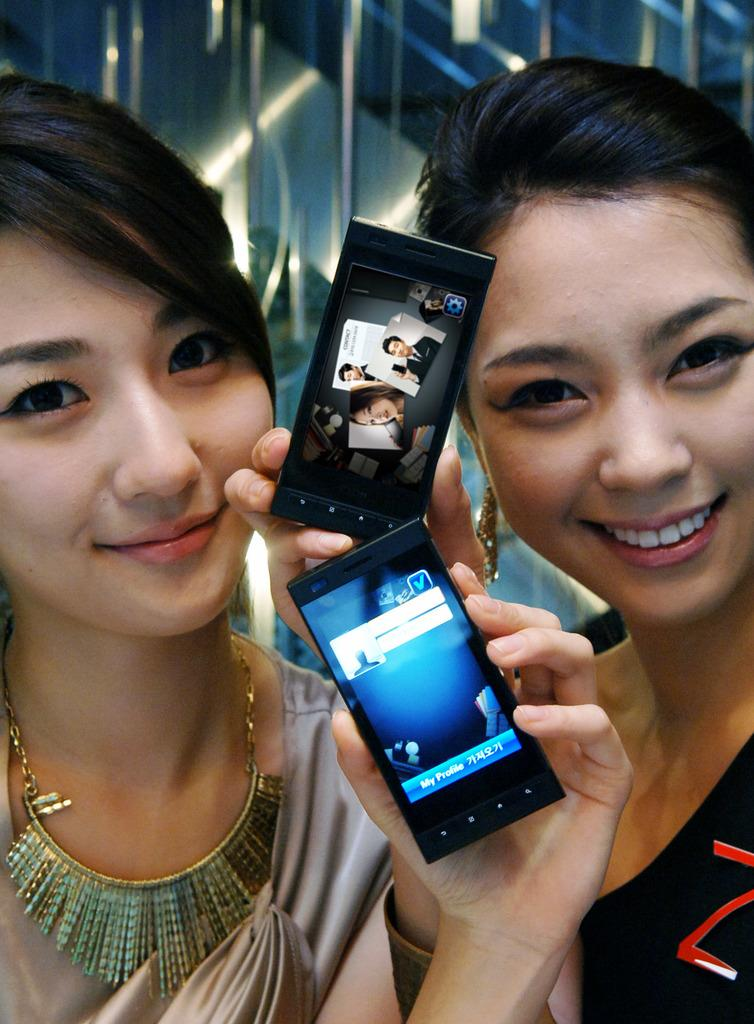What type of setting is depicted in the image? The image is of an indoor setting. Who can be seen in the image? There are two women in the foreground. What is the facial expression of the women? The women are smiling. What object are the women holding? The women are holding a mobile phone. What position do the women appear to be in? The women appear to be standing. What can be seen in the background of the image? There are lights visible in the background. What type of bedroom furniture can be seen in the image? There is no bedroom furniture present in the image; it is an indoor setting with two women holding a mobile phone. How many times do the women walk around in the image? The women do not walk around in the image; they appear to be standing. 